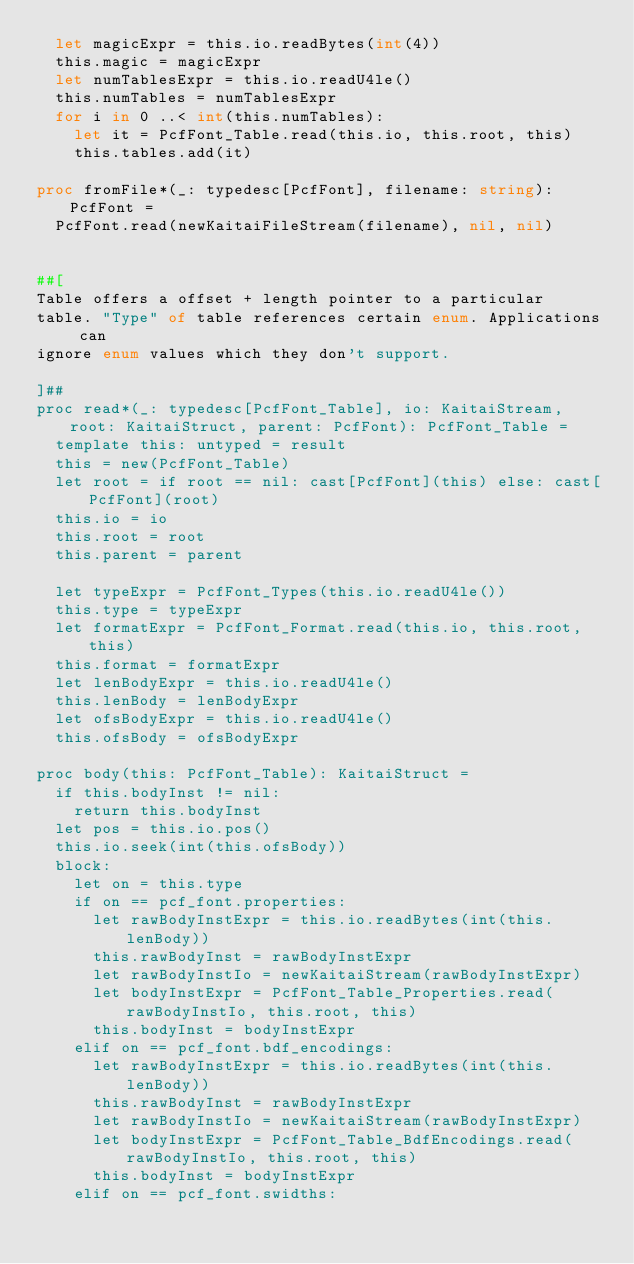<code> <loc_0><loc_0><loc_500><loc_500><_Nim_>  let magicExpr = this.io.readBytes(int(4))
  this.magic = magicExpr
  let numTablesExpr = this.io.readU4le()
  this.numTables = numTablesExpr
  for i in 0 ..< int(this.numTables):
    let it = PcfFont_Table.read(this.io, this.root, this)
    this.tables.add(it)

proc fromFile*(_: typedesc[PcfFont], filename: string): PcfFont =
  PcfFont.read(newKaitaiFileStream(filename), nil, nil)


##[
Table offers a offset + length pointer to a particular
table. "Type" of table references certain enum. Applications can
ignore enum values which they don't support.

]##
proc read*(_: typedesc[PcfFont_Table], io: KaitaiStream, root: KaitaiStruct, parent: PcfFont): PcfFont_Table =
  template this: untyped = result
  this = new(PcfFont_Table)
  let root = if root == nil: cast[PcfFont](this) else: cast[PcfFont](root)
  this.io = io
  this.root = root
  this.parent = parent

  let typeExpr = PcfFont_Types(this.io.readU4le())
  this.type = typeExpr
  let formatExpr = PcfFont_Format.read(this.io, this.root, this)
  this.format = formatExpr
  let lenBodyExpr = this.io.readU4le()
  this.lenBody = lenBodyExpr
  let ofsBodyExpr = this.io.readU4le()
  this.ofsBody = ofsBodyExpr

proc body(this: PcfFont_Table): KaitaiStruct = 
  if this.bodyInst != nil:
    return this.bodyInst
  let pos = this.io.pos()
  this.io.seek(int(this.ofsBody))
  block:
    let on = this.type
    if on == pcf_font.properties:
      let rawBodyInstExpr = this.io.readBytes(int(this.lenBody))
      this.rawBodyInst = rawBodyInstExpr
      let rawBodyInstIo = newKaitaiStream(rawBodyInstExpr)
      let bodyInstExpr = PcfFont_Table_Properties.read(rawBodyInstIo, this.root, this)
      this.bodyInst = bodyInstExpr
    elif on == pcf_font.bdf_encodings:
      let rawBodyInstExpr = this.io.readBytes(int(this.lenBody))
      this.rawBodyInst = rawBodyInstExpr
      let rawBodyInstIo = newKaitaiStream(rawBodyInstExpr)
      let bodyInstExpr = PcfFont_Table_BdfEncodings.read(rawBodyInstIo, this.root, this)
      this.bodyInst = bodyInstExpr
    elif on == pcf_font.swidths:</code> 